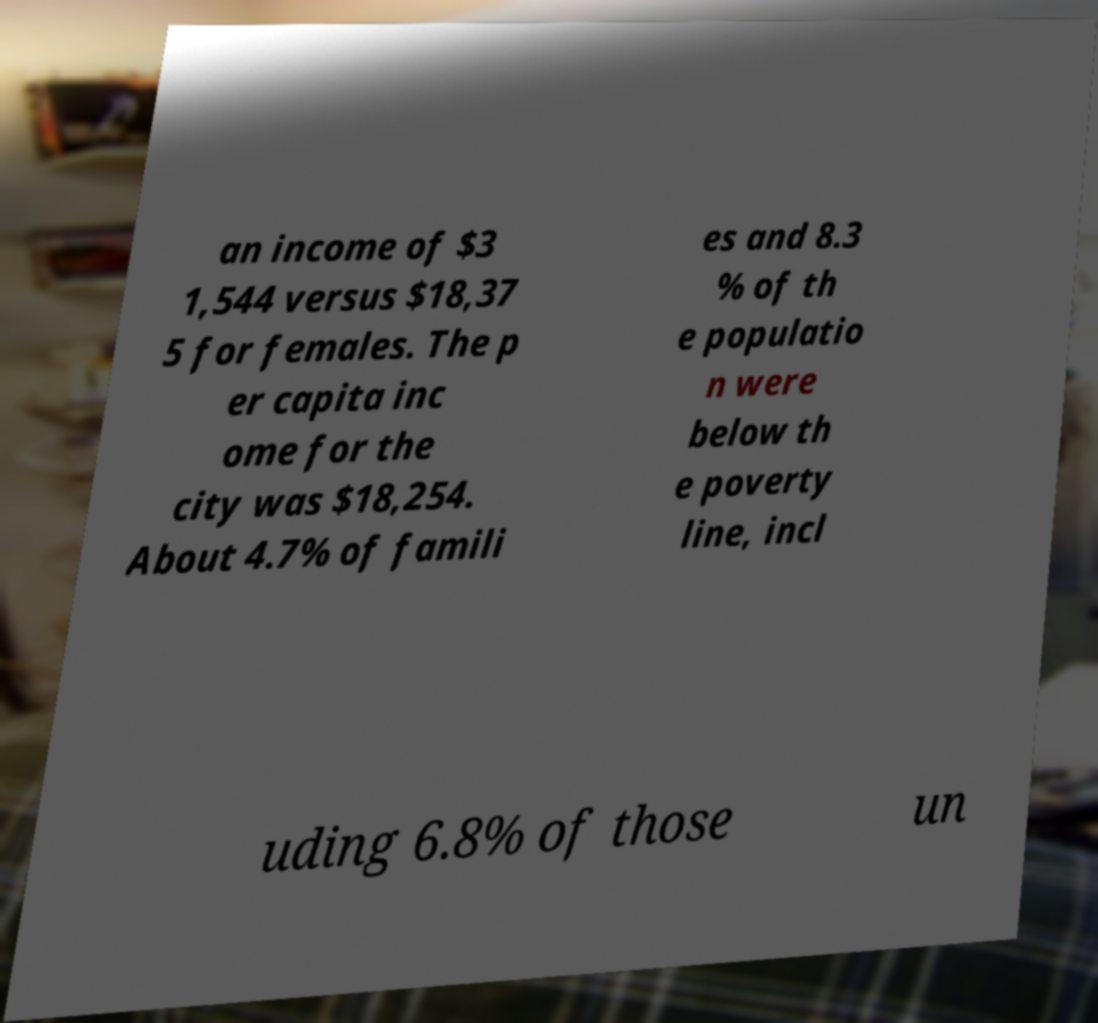There's text embedded in this image that I need extracted. Can you transcribe it verbatim? an income of $3 1,544 versus $18,37 5 for females. The p er capita inc ome for the city was $18,254. About 4.7% of famili es and 8.3 % of th e populatio n were below th e poverty line, incl uding 6.8% of those un 